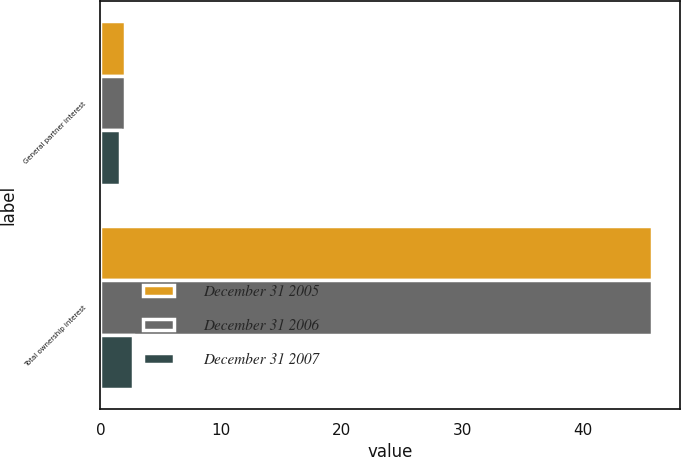Convert chart to OTSL. <chart><loc_0><loc_0><loc_500><loc_500><stacked_bar_chart><ecel><fcel>General partner interest<fcel>Total ownership interest<nl><fcel>December 31 2005<fcel>2<fcel>45.7<nl><fcel>December 31 2006<fcel>2<fcel>45.7<nl><fcel>December 31 2007<fcel>1.65<fcel>2.7<nl></chart> 